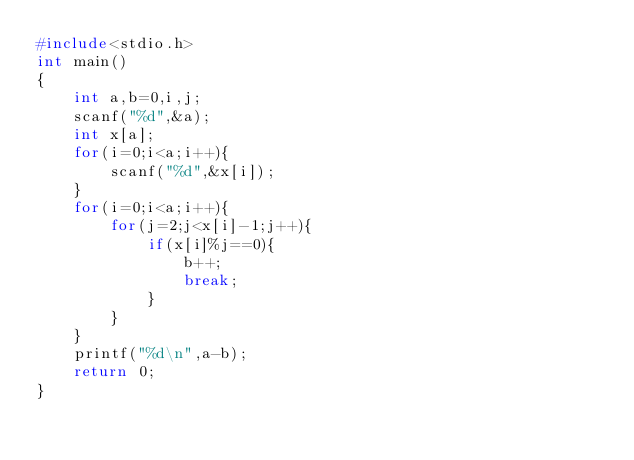Convert code to text. <code><loc_0><loc_0><loc_500><loc_500><_C_>#include<stdio.h>
int main()
{
    int a,b=0,i,j;
    scanf("%d",&a);
    int x[a];
    for(i=0;i<a;i++){
        scanf("%d",&x[i]);
    }
    for(i=0;i<a;i++){
        for(j=2;j<x[i]-1;j++){
            if(x[i]%j==0){
                b++;
                break;
            }
        }
    }
    printf("%d\n",a-b);
    return 0;
}</code> 